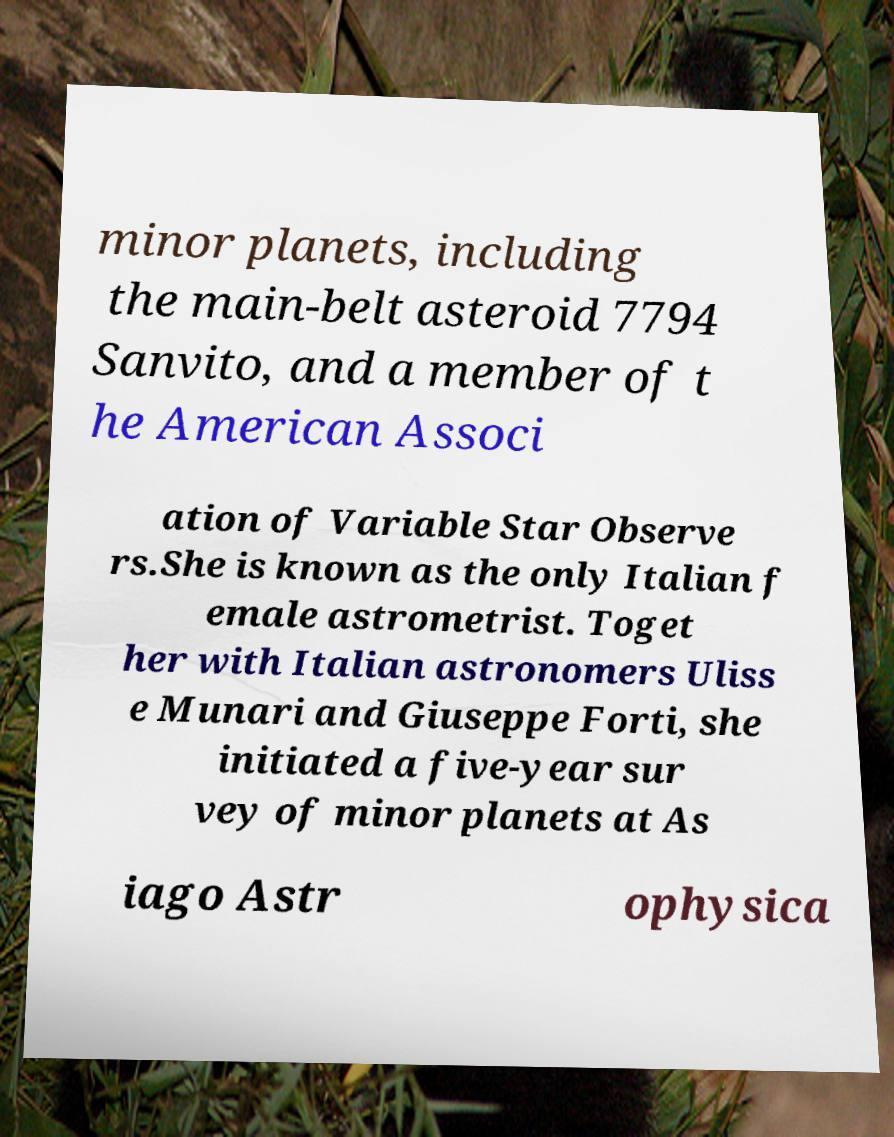Can you accurately transcribe the text from the provided image for me? minor planets, including the main-belt asteroid 7794 Sanvito, and a member of t he American Associ ation of Variable Star Observe rs.She is known as the only Italian f emale astrometrist. Toget her with Italian astronomers Uliss e Munari and Giuseppe Forti, she initiated a five-year sur vey of minor planets at As iago Astr ophysica 